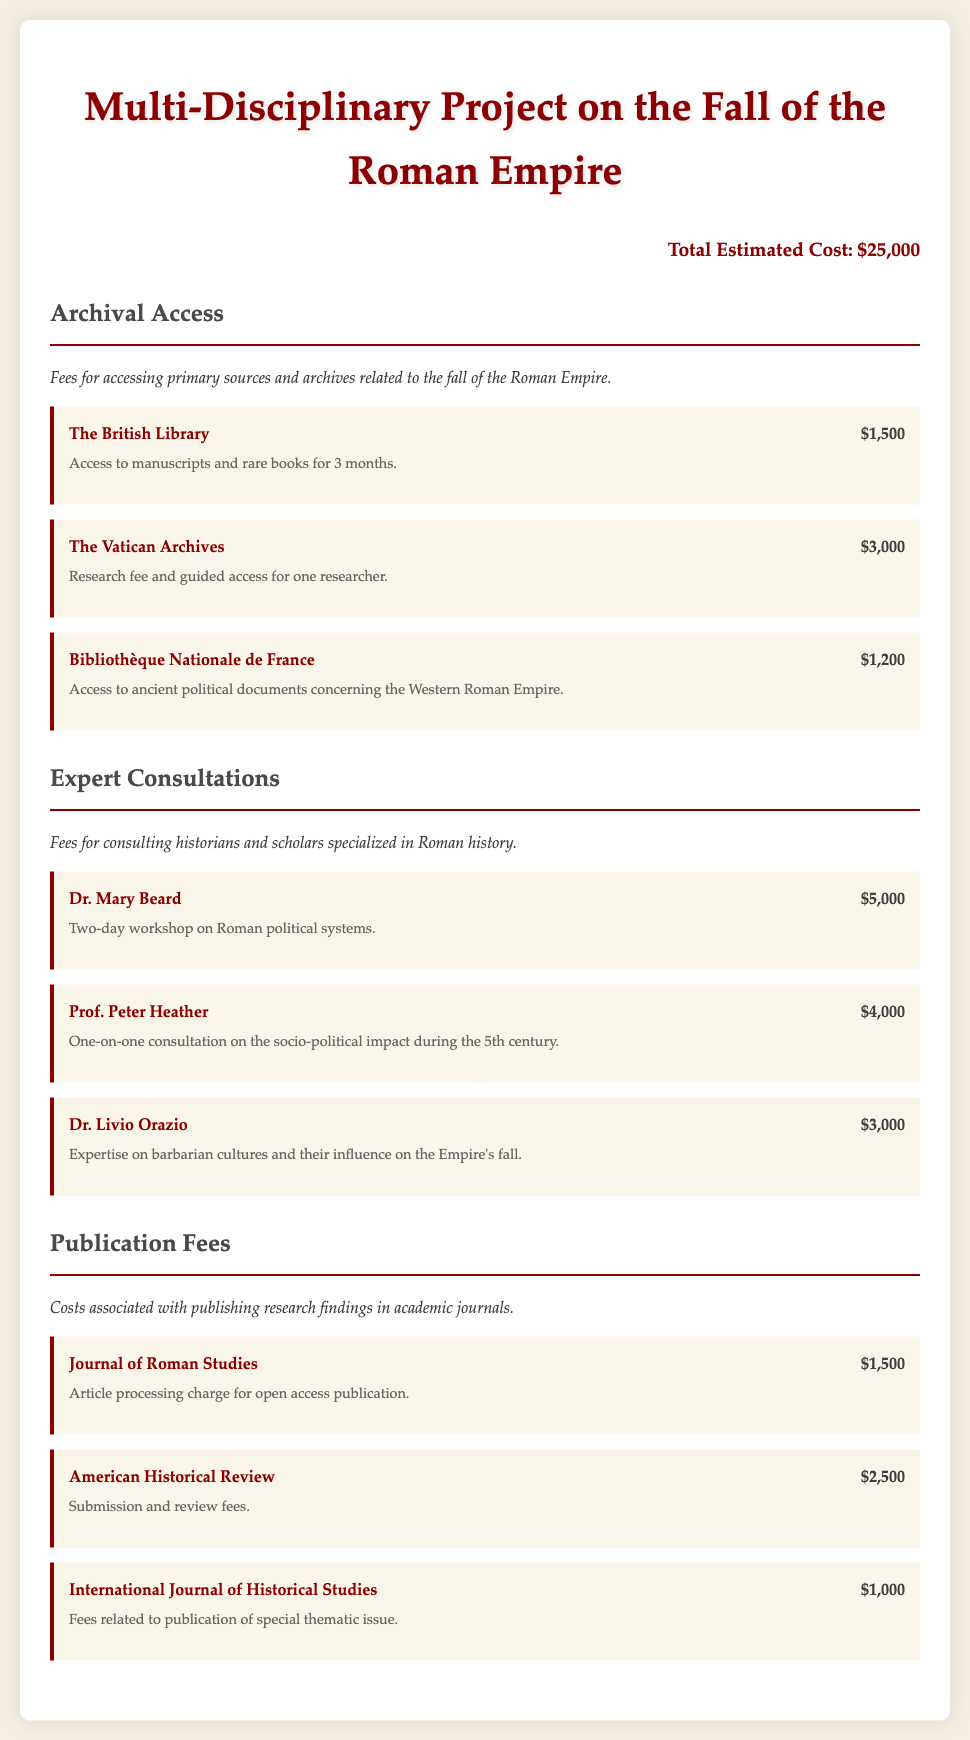What is the total estimated cost? The total estimated cost is clearly stated as $25,000 at the top of the document.
Answer: $25,000 How much is the consultation fee for Dr. Mary Beard? The fee for Dr. Mary Beard is listed as $5,000 under expert consultations.
Answer: $5,000 What archive requires the highest access fee? The Vatican Archives have the highest access fee of $3,000 listed under archival access.
Answer: $3,000 How many experts are consulted regarding the project? There are a total of three experts mentioned in the expert consultations section of the document.
Answer: Three What is the publication fee for the Journal of Roman Studies? The fee for publishing in the Journal of Roman Studies is mentioned as $1,500.
Answer: $1,500 Which archival access entity provides documents concerning the Western Roman Empire? The Bibliothèque Nationale de France provides access to ancient political documents concerning the Western Roman Empire.
Answer: Bibliothèque Nationale de France How much is the publication fee for the American Historical Review? The publication fee for the American Historical Review is specified as $2,500.
Answer: $2,500 What type of workshop will Dr. Mary Beard conduct? The workshop conducted by Dr. Mary Beard is a two-day workshop on Roman political systems.
Answer: Two-day workshop on Roman political systems What is the consultation fee for Dr. Livio Orazio? The consultation fee for Dr. Livio Orazio is listed as $3,000.
Answer: $3,000 